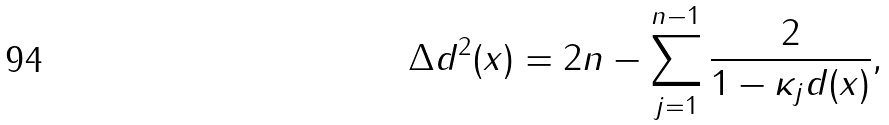Convert formula to latex. <formula><loc_0><loc_0><loc_500><loc_500>\Delta d ^ { 2 } ( x ) = 2 n - \sum _ { j = 1 } ^ { n - 1 } \frac { 2 } { 1 - \kappa _ { j } d ( x ) } ,</formula> 